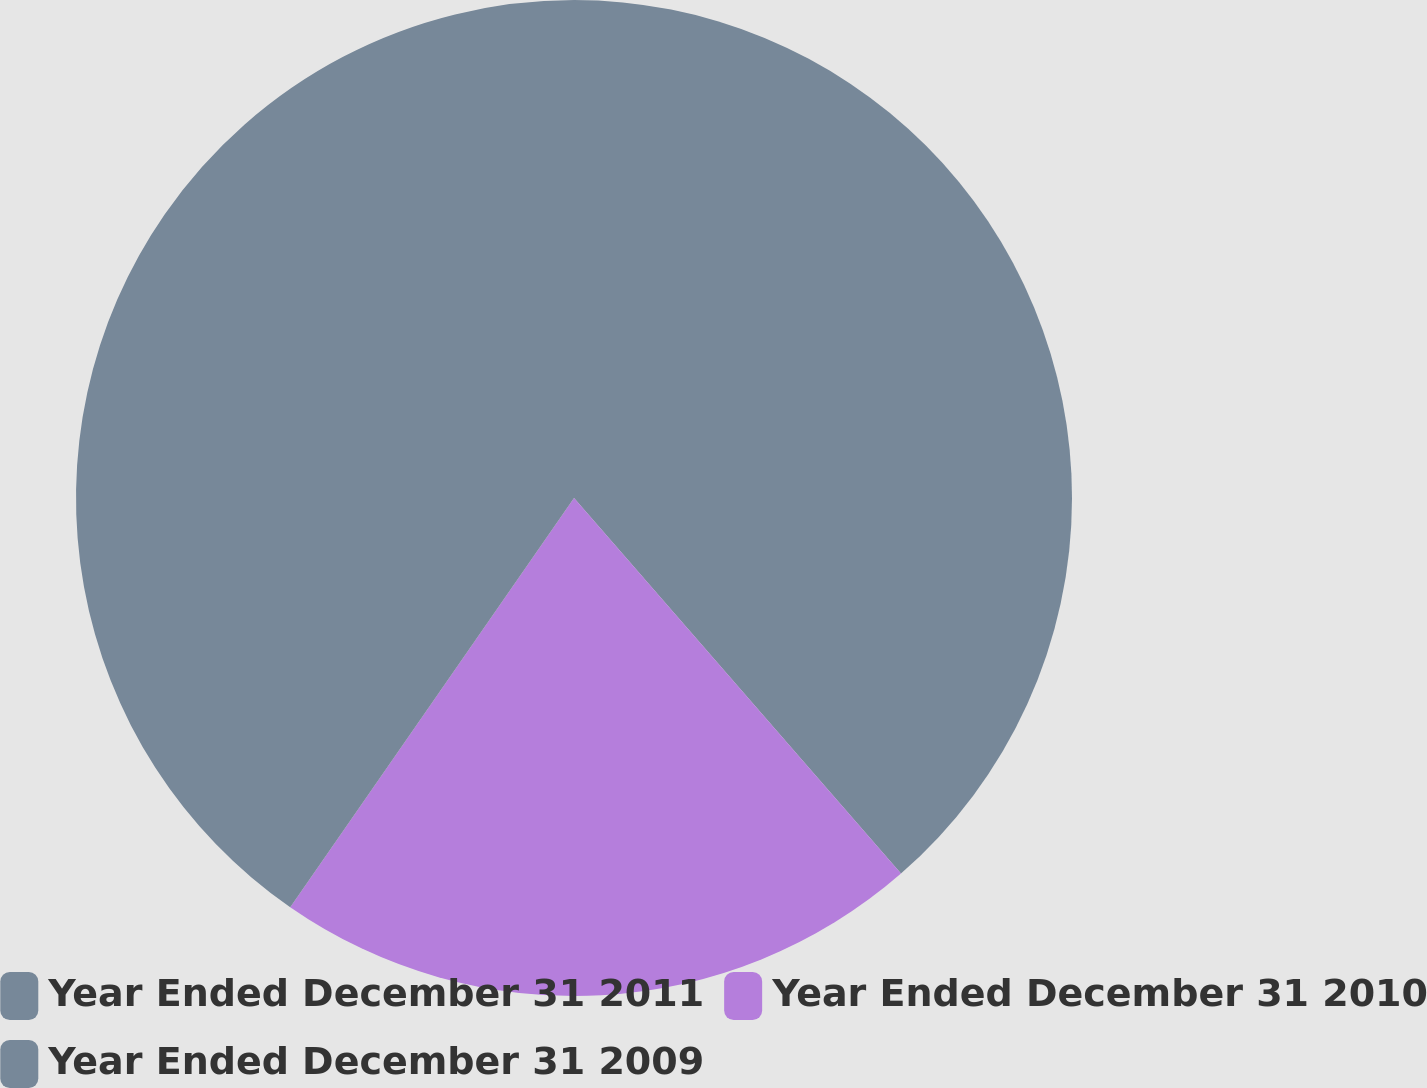Convert chart. <chart><loc_0><loc_0><loc_500><loc_500><pie_chart><fcel>Year Ended December 31 2011<fcel>Year Ended December 31 2010<fcel>Year Ended December 31 2009<nl><fcel>38.6%<fcel>21.05%<fcel>40.35%<nl></chart> 